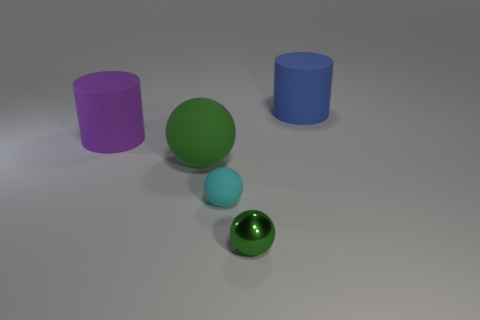Subtract all matte balls. How many balls are left? 1 Subtract all purple cylinders. How many cylinders are left? 1 Subtract all balls. How many objects are left? 2 Subtract 1 cylinders. How many cylinders are left? 1 Subtract all brown cylinders. How many cyan balls are left? 1 Add 2 red blocks. How many objects exist? 7 Subtract all red cylinders. Subtract all cyan spheres. How many cylinders are left? 2 Subtract all big gray metal balls. Subtract all blue rubber cylinders. How many objects are left? 4 Add 4 big things. How many big things are left? 7 Add 5 balls. How many balls exist? 8 